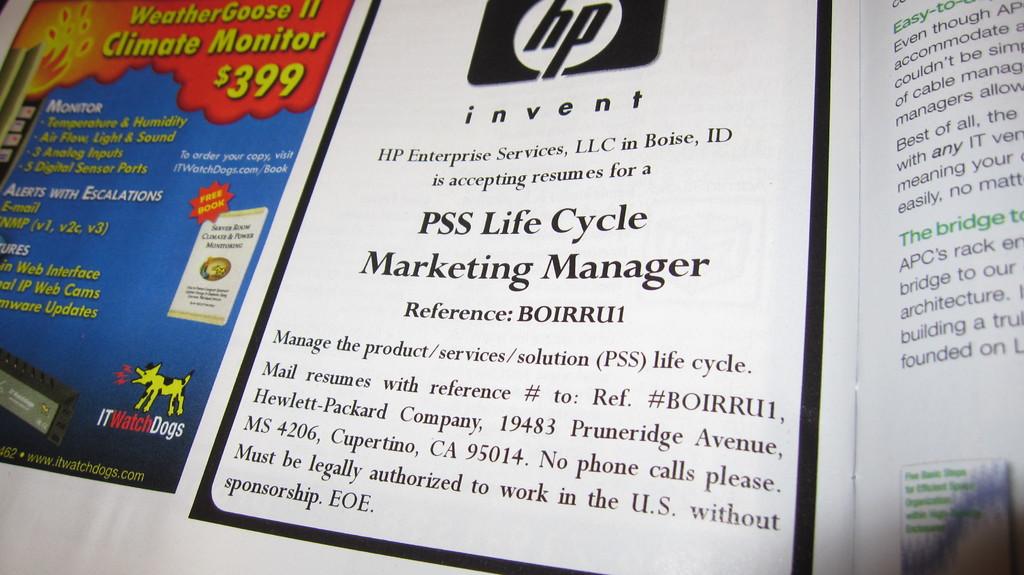What is the advertisement about?
Ensure brevity in your answer.  Climate monitor. How much does the monitor cost?
Your response must be concise. 399. 